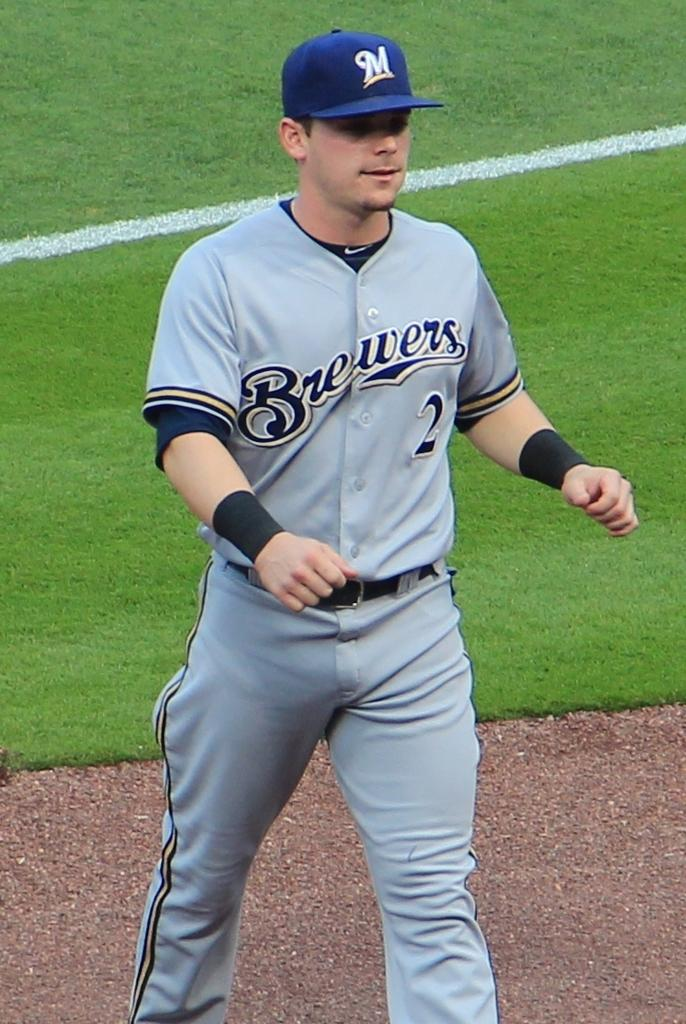Provide a one-sentence caption for the provided image. Brewers baseball player is walking on the outfield. 